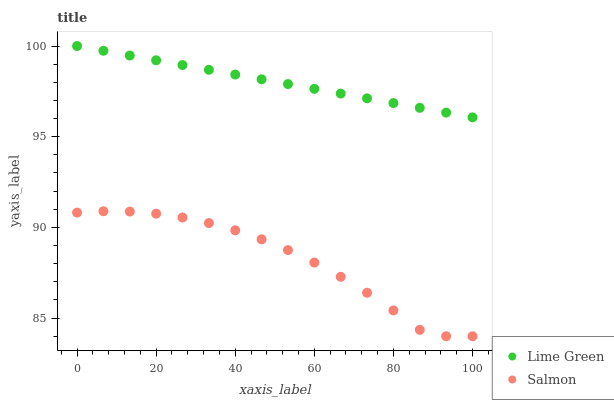Does Salmon have the minimum area under the curve?
Answer yes or no. Yes. Does Lime Green have the maximum area under the curve?
Answer yes or no. Yes. Does Lime Green have the minimum area under the curve?
Answer yes or no. No. Is Lime Green the smoothest?
Answer yes or no. Yes. Is Salmon the roughest?
Answer yes or no. Yes. Is Lime Green the roughest?
Answer yes or no. No. Does Salmon have the lowest value?
Answer yes or no. Yes. Does Lime Green have the lowest value?
Answer yes or no. No. Does Lime Green have the highest value?
Answer yes or no. Yes. Is Salmon less than Lime Green?
Answer yes or no. Yes. Is Lime Green greater than Salmon?
Answer yes or no. Yes. Does Salmon intersect Lime Green?
Answer yes or no. No. 